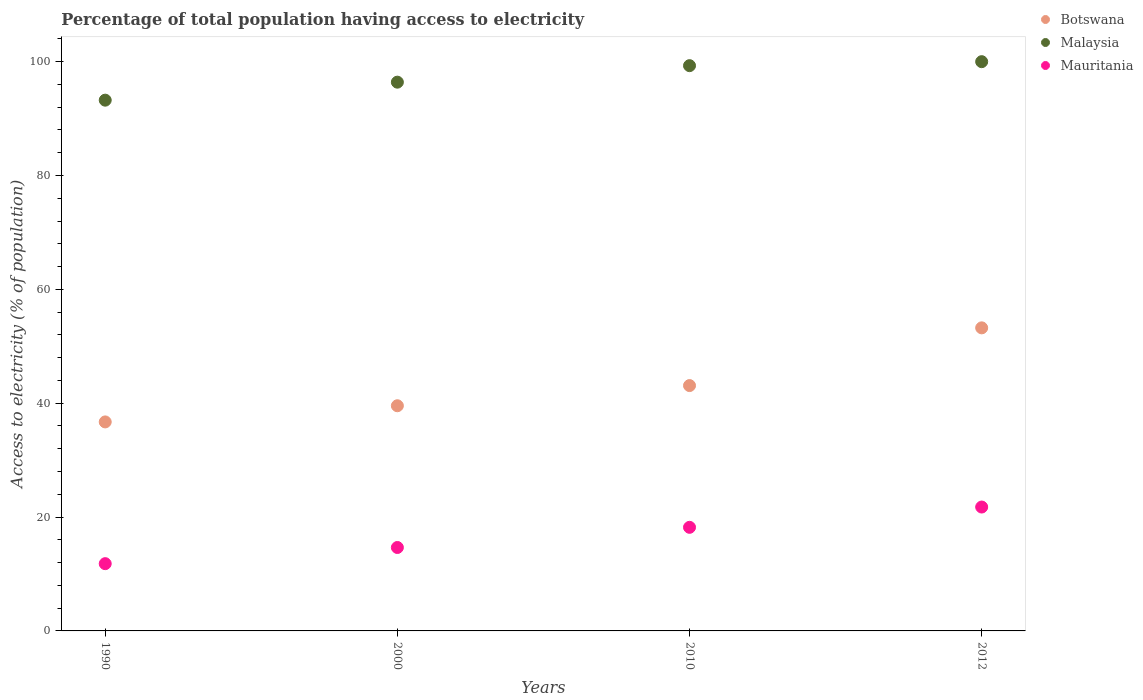What is the percentage of population that have access to electricity in Mauritania in 1990?
Make the answer very short. 11.82. Across all years, what is the maximum percentage of population that have access to electricity in Botswana?
Give a very brief answer. 53.24. Across all years, what is the minimum percentage of population that have access to electricity in Malaysia?
Give a very brief answer. 93.24. What is the total percentage of population that have access to electricity in Malaysia in the graph?
Ensure brevity in your answer.  388.94. What is the difference between the percentage of population that have access to electricity in Botswana in 1990 and that in 2012?
Provide a short and direct response. -16.52. What is the difference between the percentage of population that have access to electricity in Mauritania in 2000 and the percentage of population that have access to electricity in Botswana in 2012?
Keep it short and to the point. -38.58. What is the average percentage of population that have access to electricity in Botswana per year?
Your answer should be compact. 43.15. In the year 1990, what is the difference between the percentage of population that have access to electricity in Mauritania and percentage of population that have access to electricity in Malaysia?
Offer a terse response. -81.42. In how many years, is the percentage of population that have access to electricity in Malaysia greater than 56 %?
Your answer should be compact. 4. What is the ratio of the percentage of population that have access to electricity in Mauritania in 2000 to that in 2012?
Provide a succinct answer. 0.67. What is the difference between the highest and the second highest percentage of population that have access to electricity in Malaysia?
Your answer should be compact. 0.7. What is the difference between the highest and the lowest percentage of population that have access to electricity in Botswana?
Make the answer very short. 16.52. In how many years, is the percentage of population that have access to electricity in Botswana greater than the average percentage of population that have access to electricity in Botswana taken over all years?
Offer a very short reply. 1. Is the sum of the percentage of population that have access to electricity in Malaysia in 1990 and 2010 greater than the maximum percentage of population that have access to electricity in Mauritania across all years?
Your response must be concise. Yes. Is it the case that in every year, the sum of the percentage of population that have access to electricity in Malaysia and percentage of population that have access to electricity in Botswana  is greater than the percentage of population that have access to electricity in Mauritania?
Give a very brief answer. Yes. Is the percentage of population that have access to electricity in Malaysia strictly less than the percentage of population that have access to electricity in Botswana over the years?
Your response must be concise. No. Does the graph contain any zero values?
Keep it short and to the point. No. How many legend labels are there?
Provide a short and direct response. 3. How are the legend labels stacked?
Your answer should be very brief. Vertical. What is the title of the graph?
Make the answer very short. Percentage of total population having access to electricity. Does "Sint Maarten (Dutch part)" appear as one of the legend labels in the graph?
Keep it short and to the point. No. What is the label or title of the Y-axis?
Provide a succinct answer. Access to electricity (% of population). What is the Access to electricity (% of population) of Botswana in 1990?
Keep it short and to the point. 36.72. What is the Access to electricity (% of population) of Malaysia in 1990?
Your answer should be very brief. 93.24. What is the Access to electricity (% of population) of Mauritania in 1990?
Your response must be concise. 11.82. What is the Access to electricity (% of population) in Botswana in 2000?
Your answer should be compact. 39.56. What is the Access to electricity (% of population) in Malaysia in 2000?
Your answer should be very brief. 96.4. What is the Access to electricity (% of population) in Mauritania in 2000?
Give a very brief answer. 14.66. What is the Access to electricity (% of population) of Botswana in 2010?
Ensure brevity in your answer.  43.1. What is the Access to electricity (% of population) of Malaysia in 2010?
Keep it short and to the point. 99.3. What is the Access to electricity (% of population) in Botswana in 2012?
Your answer should be compact. 53.24. What is the Access to electricity (% of population) in Malaysia in 2012?
Make the answer very short. 100. What is the Access to electricity (% of population) in Mauritania in 2012?
Give a very brief answer. 21.76. Across all years, what is the maximum Access to electricity (% of population) in Botswana?
Keep it short and to the point. 53.24. Across all years, what is the maximum Access to electricity (% of population) of Malaysia?
Offer a terse response. 100. Across all years, what is the maximum Access to electricity (% of population) in Mauritania?
Your response must be concise. 21.76. Across all years, what is the minimum Access to electricity (% of population) of Botswana?
Your response must be concise. 36.72. Across all years, what is the minimum Access to electricity (% of population) in Malaysia?
Make the answer very short. 93.24. Across all years, what is the minimum Access to electricity (% of population) in Mauritania?
Keep it short and to the point. 11.82. What is the total Access to electricity (% of population) of Botswana in the graph?
Ensure brevity in your answer.  172.61. What is the total Access to electricity (% of population) of Malaysia in the graph?
Make the answer very short. 388.94. What is the total Access to electricity (% of population) of Mauritania in the graph?
Keep it short and to the point. 66.43. What is the difference between the Access to electricity (% of population) in Botswana in 1990 and that in 2000?
Keep it short and to the point. -2.84. What is the difference between the Access to electricity (% of population) of Malaysia in 1990 and that in 2000?
Your response must be concise. -3.16. What is the difference between the Access to electricity (% of population) in Mauritania in 1990 and that in 2000?
Give a very brief answer. -2.84. What is the difference between the Access to electricity (% of population) in Botswana in 1990 and that in 2010?
Give a very brief answer. -6.38. What is the difference between the Access to electricity (% of population) of Malaysia in 1990 and that in 2010?
Your response must be concise. -6.06. What is the difference between the Access to electricity (% of population) in Mauritania in 1990 and that in 2010?
Offer a very short reply. -6.38. What is the difference between the Access to electricity (% of population) in Botswana in 1990 and that in 2012?
Your response must be concise. -16.52. What is the difference between the Access to electricity (% of population) in Malaysia in 1990 and that in 2012?
Offer a very short reply. -6.76. What is the difference between the Access to electricity (% of population) of Mauritania in 1990 and that in 2012?
Your response must be concise. -9.95. What is the difference between the Access to electricity (% of population) in Botswana in 2000 and that in 2010?
Offer a very short reply. -3.54. What is the difference between the Access to electricity (% of population) in Mauritania in 2000 and that in 2010?
Keep it short and to the point. -3.54. What is the difference between the Access to electricity (% of population) of Botswana in 2000 and that in 2012?
Your answer should be compact. -13.68. What is the difference between the Access to electricity (% of population) of Mauritania in 2000 and that in 2012?
Your answer should be very brief. -7.11. What is the difference between the Access to electricity (% of population) of Botswana in 2010 and that in 2012?
Make the answer very short. -10.14. What is the difference between the Access to electricity (% of population) in Malaysia in 2010 and that in 2012?
Provide a short and direct response. -0.7. What is the difference between the Access to electricity (% of population) of Mauritania in 2010 and that in 2012?
Ensure brevity in your answer.  -3.56. What is the difference between the Access to electricity (% of population) of Botswana in 1990 and the Access to electricity (% of population) of Malaysia in 2000?
Give a very brief answer. -59.68. What is the difference between the Access to electricity (% of population) in Botswana in 1990 and the Access to electricity (% of population) in Mauritania in 2000?
Your response must be concise. 22.06. What is the difference between the Access to electricity (% of population) in Malaysia in 1990 and the Access to electricity (% of population) in Mauritania in 2000?
Keep it short and to the point. 78.58. What is the difference between the Access to electricity (% of population) of Botswana in 1990 and the Access to electricity (% of population) of Malaysia in 2010?
Ensure brevity in your answer.  -62.58. What is the difference between the Access to electricity (% of population) in Botswana in 1990 and the Access to electricity (% of population) in Mauritania in 2010?
Keep it short and to the point. 18.52. What is the difference between the Access to electricity (% of population) of Malaysia in 1990 and the Access to electricity (% of population) of Mauritania in 2010?
Your response must be concise. 75.04. What is the difference between the Access to electricity (% of population) of Botswana in 1990 and the Access to electricity (% of population) of Malaysia in 2012?
Your response must be concise. -63.28. What is the difference between the Access to electricity (% of population) in Botswana in 1990 and the Access to electricity (% of population) in Mauritania in 2012?
Give a very brief answer. 14.95. What is the difference between the Access to electricity (% of population) of Malaysia in 1990 and the Access to electricity (% of population) of Mauritania in 2012?
Your answer should be very brief. 71.48. What is the difference between the Access to electricity (% of population) in Botswana in 2000 and the Access to electricity (% of population) in Malaysia in 2010?
Keep it short and to the point. -59.74. What is the difference between the Access to electricity (% of population) in Botswana in 2000 and the Access to electricity (% of population) in Mauritania in 2010?
Offer a terse response. 21.36. What is the difference between the Access to electricity (% of population) of Malaysia in 2000 and the Access to electricity (% of population) of Mauritania in 2010?
Your answer should be very brief. 78.2. What is the difference between the Access to electricity (% of population) of Botswana in 2000 and the Access to electricity (% of population) of Malaysia in 2012?
Your answer should be compact. -60.44. What is the difference between the Access to electricity (% of population) in Botswana in 2000 and the Access to electricity (% of population) in Mauritania in 2012?
Offer a terse response. 17.79. What is the difference between the Access to electricity (% of population) in Malaysia in 2000 and the Access to electricity (% of population) in Mauritania in 2012?
Provide a short and direct response. 74.64. What is the difference between the Access to electricity (% of population) in Botswana in 2010 and the Access to electricity (% of population) in Malaysia in 2012?
Offer a very short reply. -56.9. What is the difference between the Access to electricity (% of population) of Botswana in 2010 and the Access to electricity (% of population) of Mauritania in 2012?
Provide a succinct answer. 21.34. What is the difference between the Access to electricity (% of population) in Malaysia in 2010 and the Access to electricity (% of population) in Mauritania in 2012?
Keep it short and to the point. 77.54. What is the average Access to electricity (% of population) of Botswana per year?
Your answer should be compact. 43.15. What is the average Access to electricity (% of population) of Malaysia per year?
Keep it short and to the point. 97.23. What is the average Access to electricity (% of population) of Mauritania per year?
Ensure brevity in your answer.  16.61. In the year 1990, what is the difference between the Access to electricity (% of population) in Botswana and Access to electricity (% of population) in Malaysia?
Ensure brevity in your answer.  -56.52. In the year 1990, what is the difference between the Access to electricity (% of population) of Botswana and Access to electricity (% of population) of Mauritania?
Ensure brevity in your answer.  24.9. In the year 1990, what is the difference between the Access to electricity (% of population) of Malaysia and Access to electricity (% of population) of Mauritania?
Ensure brevity in your answer.  81.42. In the year 2000, what is the difference between the Access to electricity (% of population) of Botswana and Access to electricity (% of population) of Malaysia?
Offer a very short reply. -56.84. In the year 2000, what is the difference between the Access to electricity (% of population) in Botswana and Access to electricity (% of population) in Mauritania?
Keep it short and to the point. 24.9. In the year 2000, what is the difference between the Access to electricity (% of population) in Malaysia and Access to electricity (% of population) in Mauritania?
Your response must be concise. 81.74. In the year 2010, what is the difference between the Access to electricity (% of population) of Botswana and Access to electricity (% of population) of Malaysia?
Give a very brief answer. -56.2. In the year 2010, what is the difference between the Access to electricity (% of population) in Botswana and Access to electricity (% of population) in Mauritania?
Provide a short and direct response. 24.9. In the year 2010, what is the difference between the Access to electricity (% of population) of Malaysia and Access to electricity (% of population) of Mauritania?
Provide a short and direct response. 81.1. In the year 2012, what is the difference between the Access to electricity (% of population) in Botswana and Access to electricity (% of population) in Malaysia?
Your answer should be compact. -46.76. In the year 2012, what is the difference between the Access to electricity (% of population) of Botswana and Access to electricity (% of population) of Mauritania?
Provide a succinct answer. 31.48. In the year 2012, what is the difference between the Access to electricity (% of population) in Malaysia and Access to electricity (% of population) in Mauritania?
Give a very brief answer. 78.24. What is the ratio of the Access to electricity (% of population) in Botswana in 1990 to that in 2000?
Offer a very short reply. 0.93. What is the ratio of the Access to electricity (% of population) of Malaysia in 1990 to that in 2000?
Your answer should be compact. 0.97. What is the ratio of the Access to electricity (% of population) in Mauritania in 1990 to that in 2000?
Your answer should be compact. 0.81. What is the ratio of the Access to electricity (% of population) in Botswana in 1990 to that in 2010?
Make the answer very short. 0.85. What is the ratio of the Access to electricity (% of population) in Malaysia in 1990 to that in 2010?
Offer a very short reply. 0.94. What is the ratio of the Access to electricity (% of population) in Mauritania in 1990 to that in 2010?
Make the answer very short. 0.65. What is the ratio of the Access to electricity (% of population) of Botswana in 1990 to that in 2012?
Your response must be concise. 0.69. What is the ratio of the Access to electricity (% of population) of Malaysia in 1990 to that in 2012?
Offer a very short reply. 0.93. What is the ratio of the Access to electricity (% of population) of Mauritania in 1990 to that in 2012?
Keep it short and to the point. 0.54. What is the ratio of the Access to electricity (% of population) of Botswana in 2000 to that in 2010?
Offer a very short reply. 0.92. What is the ratio of the Access to electricity (% of population) of Malaysia in 2000 to that in 2010?
Give a very brief answer. 0.97. What is the ratio of the Access to electricity (% of population) in Mauritania in 2000 to that in 2010?
Offer a very short reply. 0.81. What is the ratio of the Access to electricity (% of population) of Botswana in 2000 to that in 2012?
Offer a very short reply. 0.74. What is the ratio of the Access to electricity (% of population) of Mauritania in 2000 to that in 2012?
Ensure brevity in your answer.  0.67. What is the ratio of the Access to electricity (% of population) of Botswana in 2010 to that in 2012?
Your response must be concise. 0.81. What is the ratio of the Access to electricity (% of population) of Mauritania in 2010 to that in 2012?
Offer a terse response. 0.84. What is the difference between the highest and the second highest Access to electricity (% of population) in Botswana?
Your answer should be compact. 10.14. What is the difference between the highest and the second highest Access to electricity (% of population) of Mauritania?
Ensure brevity in your answer.  3.56. What is the difference between the highest and the lowest Access to electricity (% of population) of Botswana?
Offer a very short reply. 16.52. What is the difference between the highest and the lowest Access to electricity (% of population) of Malaysia?
Give a very brief answer. 6.76. What is the difference between the highest and the lowest Access to electricity (% of population) in Mauritania?
Provide a succinct answer. 9.95. 